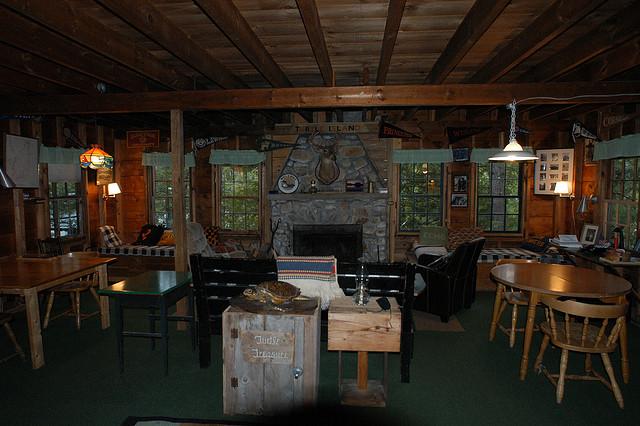Could this be early evening?
Answer briefly. Yes. Is there anyone in this room?
Quick response, please. No. What color is the wall?
Give a very brief answer. Brown. How many light fixtures are on?
Write a very short answer. 4. 